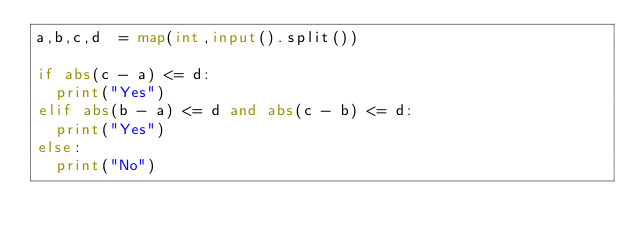Convert code to text. <code><loc_0><loc_0><loc_500><loc_500><_Python_>a,b,c,d  = map(int,input().split())

if abs(c - a) <= d:
	print("Yes")
elif abs(b - a) <= d and abs(c - b) <= d:
	print("Yes")
else:
	print("No")</code> 